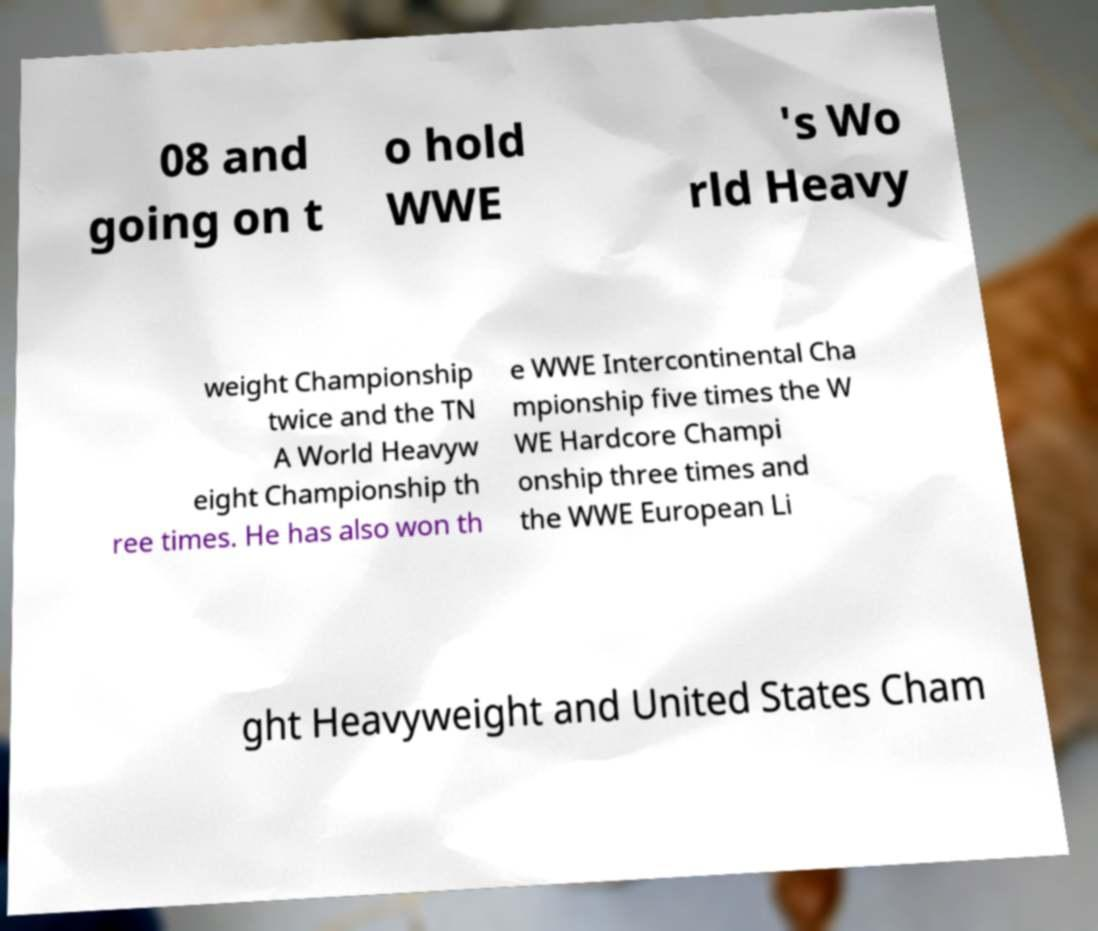Can you read and provide the text displayed in the image?This photo seems to have some interesting text. Can you extract and type it out for me? 08 and going on t o hold WWE 's Wo rld Heavy weight Championship twice and the TN A World Heavyw eight Championship th ree times. He has also won th e WWE Intercontinental Cha mpionship five times the W WE Hardcore Champi onship three times and the WWE European Li ght Heavyweight and United States Cham 